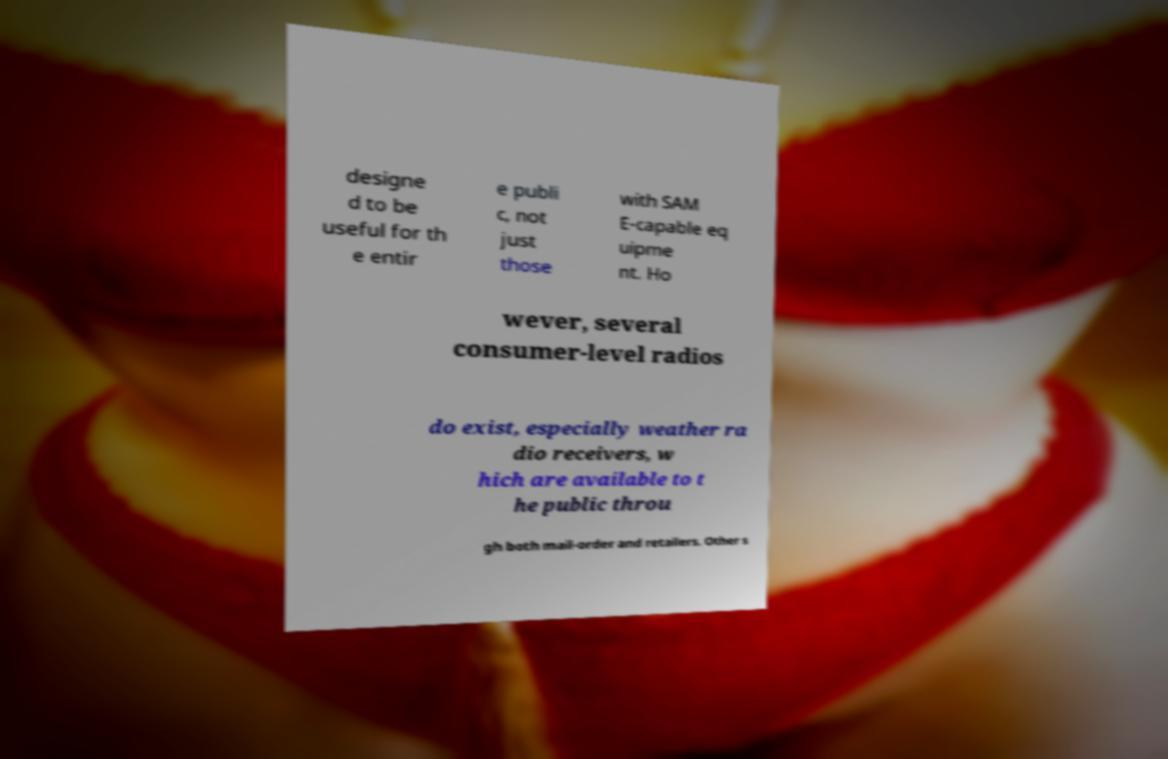Can you read and provide the text displayed in the image?This photo seems to have some interesting text. Can you extract and type it out for me? designe d to be useful for th e entir e publi c, not just those with SAM E-capable eq uipme nt. Ho wever, several consumer-level radios do exist, especially weather ra dio receivers, w hich are available to t he public throu gh both mail-order and retailers. Other s 